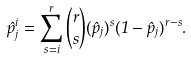Convert formula to latex. <formula><loc_0><loc_0><loc_500><loc_500>\hat { p } _ { j } ^ { i } = \sum _ { s = i } ^ { r } \binom { r } { s } ( \hat { p } _ { j } ) ^ { s } ( 1 - \hat { p } _ { j } ) ^ { r - s } .</formula> 